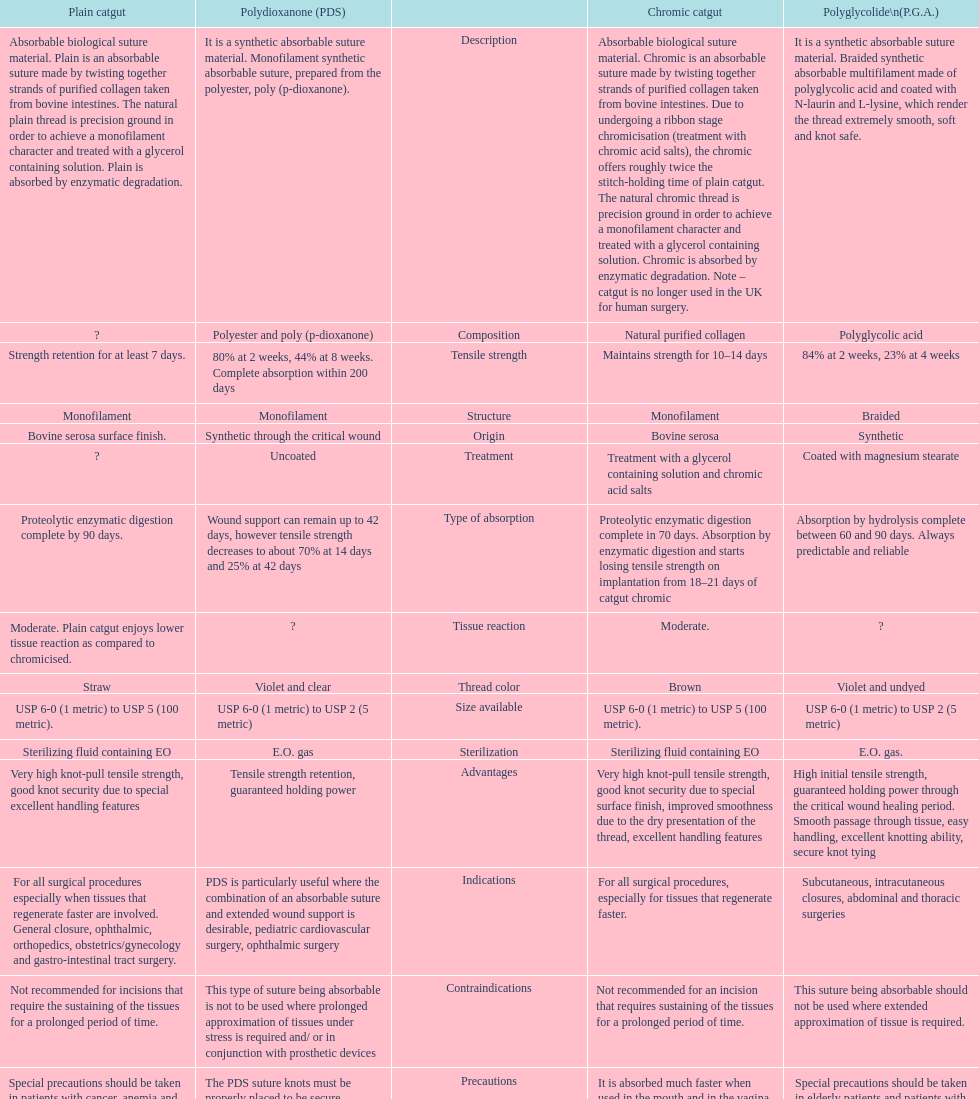In the uk, what category of sutures is no longer employed for surgical procedures on humans? Chromic catgut. 